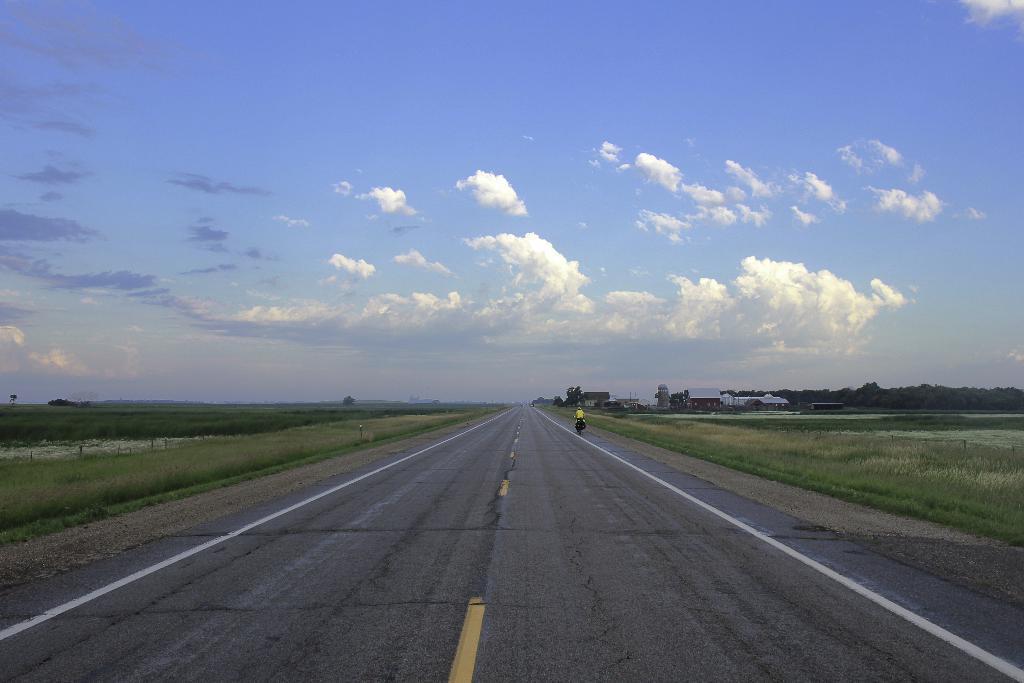Can you describe this image briefly? In this image I can see the road, some grass on both sides of the road and a person riding a vehicle on the road. In the background I can see few buildings, few trees and the sky. 